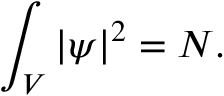Convert formula to latex. <formula><loc_0><loc_0><loc_500><loc_500>\int _ { V } | \psi | ^ { 2 } = N .</formula> 